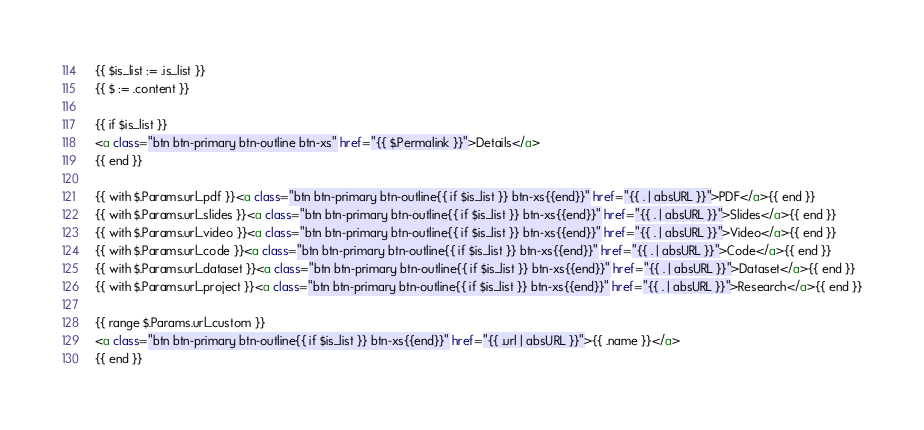<code> <loc_0><loc_0><loc_500><loc_500><_HTML_>{{ $is_list := .is_list }}
{{ $ := .content }}

{{ if $is_list }}
<a class="btn btn-primary btn-outline btn-xs" href="{{ $.Permalink }}">Details</a>
{{ end }}

{{ with $.Params.url_pdf }}<a class="btn btn-primary btn-outline{{ if $is_list }} btn-xs{{end}}" href="{{ . | absURL }}">PDF</a>{{ end }}
{{ with $.Params.url_slides }}<a class="btn btn-primary btn-outline{{ if $is_list }} btn-xs{{end}}" href="{{ . | absURL }}">Slides</a>{{ end }}
{{ with $.Params.url_video }}<a class="btn btn-primary btn-outline{{ if $is_list }} btn-xs{{end}}" href="{{ . | absURL }}">Video</a>{{ end }}
{{ with $.Params.url_code }}<a class="btn btn-primary btn-outline{{ if $is_list }} btn-xs{{end}}" href="{{ . | absURL }}">Code</a>{{ end }}
{{ with $.Params.url_dataset }}<a class="btn btn-primary btn-outline{{ if $is_list }} btn-xs{{end}}" href="{{ . | absURL }}">Dataset</a>{{ end }}
{{ with $.Params.url_project }}<a class="btn btn-primary btn-outline{{ if $is_list }} btn-xs{{end}}" href="{{ . | absURL }}">Research</a>{{ end }}

{{ range $.Params.url_custom }}
<a class="btn btn-primary btn-outline{{ if $is_list }} btn-xs{{end}}" href="{{ .url | absURL }}">{{ .name }}</a>
{{ end }}
</code> 